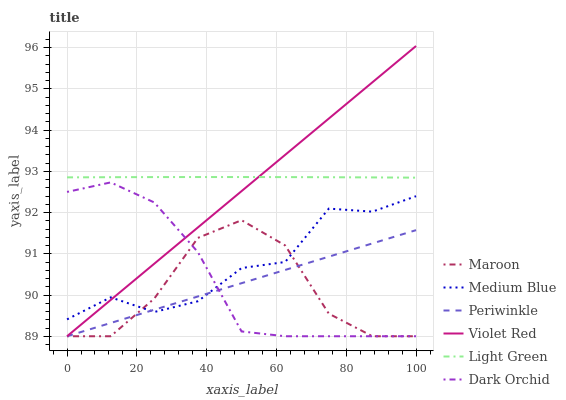Does Maroon have the minimum area under the curve?
Answer yes or no. Yes. Does Light Green have the maximum area under the curve?
Answer yes or no. Yes. Does Medium Blue have the minimum area under the curve?
Answer yes or no. No. Does Medium Blue have the maximum area under the curve?
Answer yes or no. No. Is Periwinkle the smoothest?
Answer yes or no. Yes. Is Maroon the roughest?
Answer yes or no. Yes. Is Medium Blue the smoothest?
Answer yes or no. No. Is Medium Blue the roughest?
Answer yes or no. No. Does Violet Red have the lowest value?
Answer yes or no. Yes. Does Medium Blue have the lowest value?
Answer yes or no. No. Does Violet Red have the highest value?
Answer yes or no. Yes. Does Medium Blue have the highest value?
Answer yes or no. No. Is Maroon less than Light Green?
Answer yes or no. Yes. Is Light Green greater than Dark Orchid?
Answer yes or no. Yes. Does Violet Red intersect Maroon?
Answer yes or no. Yes. Is Violet Red less than Maroon?
Answer yes or no. No. Is Violet Red greater than Maroon?
Answer yes or no. No. Does Maroon intersect Light Green?
Answer yes or no. No. 